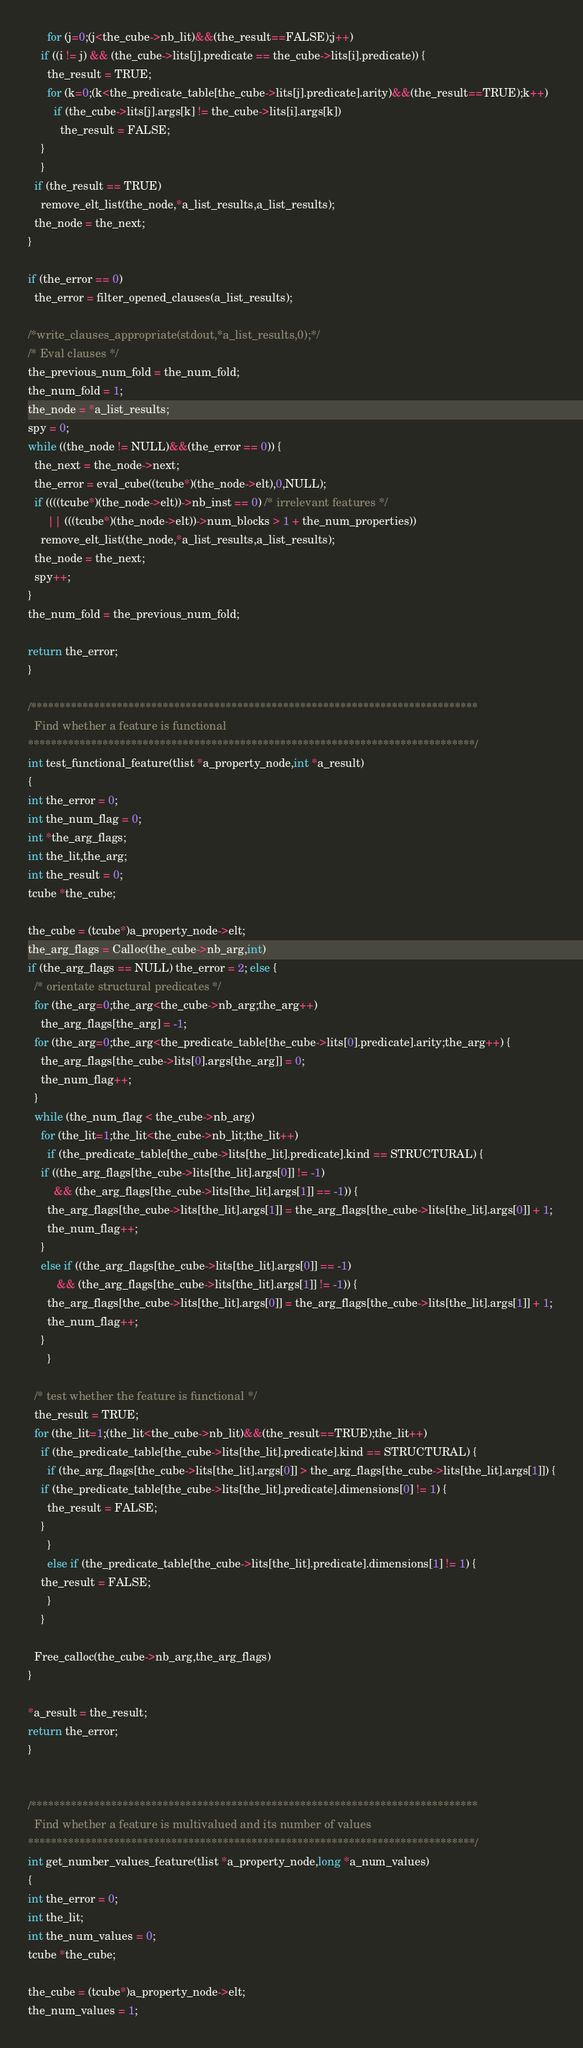Convert code to text. <code><loc_0><loc_0><loc_500><loc_500><_C_>      for (j=0;(j<the_cube->nb_lit)&&(the_result==FALSE);j++)
	if ((i != j) && (the_cube->lits[j].predicate == the_cube->lits[i].predicate)) {
	  the_result = TRUE;
	  for (k=0;(k<the_predicate_table[the_cube->lits[j].predicate].arity)&&(the_result==TRUE);k++)
	    if (the_cube->lits[j].args[k] != the_cube->lits[i].args[k])
	      the_result = FALSE;
	}      
    }
  if (the_result == TRUE)
    remove_elt_list(the_node,*a_list_results,a_list_results);
  the_node = the_next;
}

if (the_error == 0)
  the_error = filter_opened_clauses(a_list_results);

/*write_clauses_appropriate(stdout,*a_list_results,0);*/
/* Eval clauses */
the_previous_num_fold = the_num_fold;
the_num_fold = 1;
the_node = *a_list_results;
spy = 0;
while ((the_node != NULL)&&(the_error == 0)) {
  the_next = the_node->next;
  the_error = eval_cube((tcube*)(the_node->elt),0,NULL);
  if ((((tcube*)(the_node->elt))->nb_inst == 0) /* irrelevant features */
      || (((tcube*)(the_node->elt))->num_blocks > 1 + the_num_properties))
    remove_elt_list(the_node,*a_list_results,a_list_results);
  the_node = the_next;
  spy++;
}
the_num_fold = the_previous_num_fold;

return the_error;
}

/******************************************************************************
  Find whether a feature is functional
******************************************************************************/
int test_functional_feature(tlist *a_property_node,int *a_result)
{
int the_error = 0;
int the_num_flag = 0;
int *the_arg_flags;
int the_lit,the_arg;
int the_result = 0;
tcube *the_cube;

the_cube = (tcube*)a_property_node->elt;
the_arg_flags = Calloc(the_cube->nb_arg,int)
if (the_arg_flags == NULL) the_error = 2; else {
  /* orientate structural predicates */
  for (the_arg=0;the_arg<the_cube->nb_arg;the_arg++)
    the_arg_flags[the_arg] = -1;
  for (the_arg=0;the_arg<the_predicate_table[the_cube->lits[0].predicate].arity;the_arg++) {
    the_arg_flags[the_cube->lits[0].args[the_arg]] = 0;
    the_num_flag++;
  }
  while (the_num_flag < the_cube->nb_arg)
    for (the_lit=1;the_lit<the_cube->nb_lit;the_lit++)
      if (the_predicate_table[the_cube->lits[the_lit].predicate].kind == STRUCTURAL) {
	if ((the_arg_flags[the_cube->lits[the_lit].args[0]] != -1)
	    && (the_arg_flags[the_cube->lits[the_lit].args[1]] == -1)) {
	  the_arg_flags[the_cube->lits[the_lit].args[1]] = the_arg_flags[the_cube->lits[the_lit].args[0]] + 1;
	  the_num_flag++;
	}
	else if ((the_arg_flags[the_cube->lits[the_lit].args[0]] == -1)
		 && (the_arg_flags[the_cube->lits[the_lit].args[1]] != -1)) {
	  the_arg_flags[the_cube->lits[the_lit].args[0]] = the_arg_flags[the_cube->lits[the_lit].args[1]] + 1;
	  the_num_flag++;
	}
      }

  /* test whether the feature is functional */
  the_result = TRUE;
  for (the_lit=1;(the_lit<the_cube->nb_lit)&&(the_result==TRUE);the_lit++)
    if (the_predicate_table[the_cube->lits[the_lit].predicate].kind == STRUCTURAL) {
      if (the_arg_flags[the_cube->lits[the_lit].args[0]] > the_arg_flags[the_cube->lits[the_lit].args[1]]) {
	if (the_predicate_table[the_cube->lits[the_lit].predicate].dimensions[0] != 1) {
	  the_result = FALSE;
	}
      }
      else if (the_predicate_table[the_cube->lits[the_lit].predicate].dimensions[1] != 1) {
	the_result = FALSE;
      }
    }

  Free_calloc(the_cube->nb_arg,the_arg_flags)
}

*a_result = the_result;
return the_error;
}


/******************************************************************************
  Find whether a feature is multivalued and its number of values
******************************************************************************/
int get_number_values_feature(tlist *a_property_node,long *a_num_values)
{
int the_error = 0;
int the_lit;
int the_num_values = 0;
tcube *the_cube;

the_cube = (tcube*)a_property_node->elt;
the_num_values = 1;</code> 